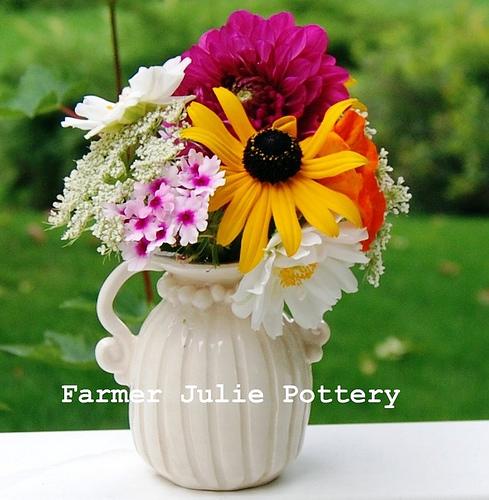What color is the pitcher?
Answer briefly. White. Are these flowers made of plastic?
Answer briefly. No. Does this look like an ad?
Answer briefly. Yes. 